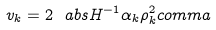<formula> <loc_0><loc_0><loc_500><loc_500>v _ { k } = 2 \ a b s { H ^ { - 1 } \alpha _ { k } } \rho _ { k } ^ { 2 } c o m m a</formula> 